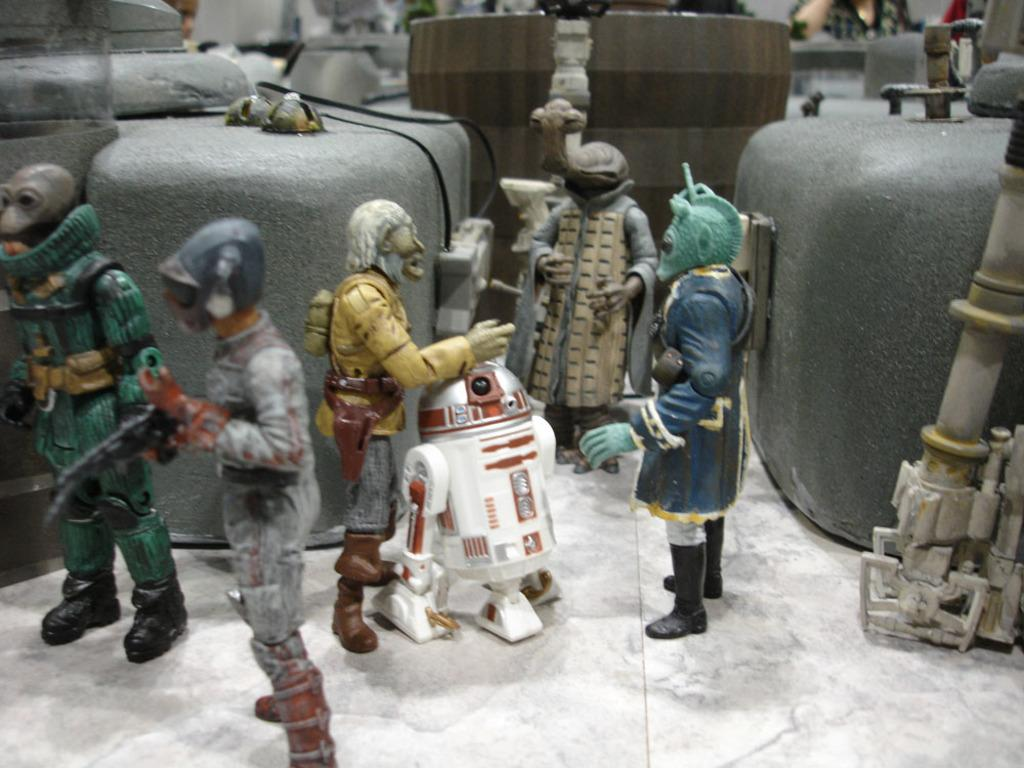What types of objects are in the front of the image? There are toys in the front of the image. Can you describe the main toy in the image? There is a white robot toy in the center of the image. What else can be seen in the image besides the toys? There are other objects visible at the back of the image. What is the name of the tomato plant in the image? There is no tomato plant present in the image. How many tomatoes can be seen shaking in the image? There are no tomatoes or shaking motion present in the image. 